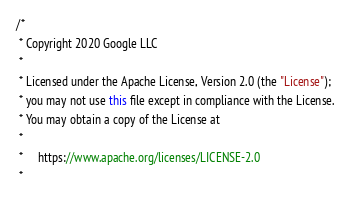Convert code to text. <code><loc_0><loc_0><loc_500><loc_500><_Java_>/*
 * Copyright 2020 Google LLC
 *
 * Licensed under the Apache License, Version 2.0 (the "License");
 * you may not use this file except in compliance with the License.
 * You may obtain a copy of the License at
 *
 *     https://www.apache.org/licenses/LICENSE-2.0
 *</code> 